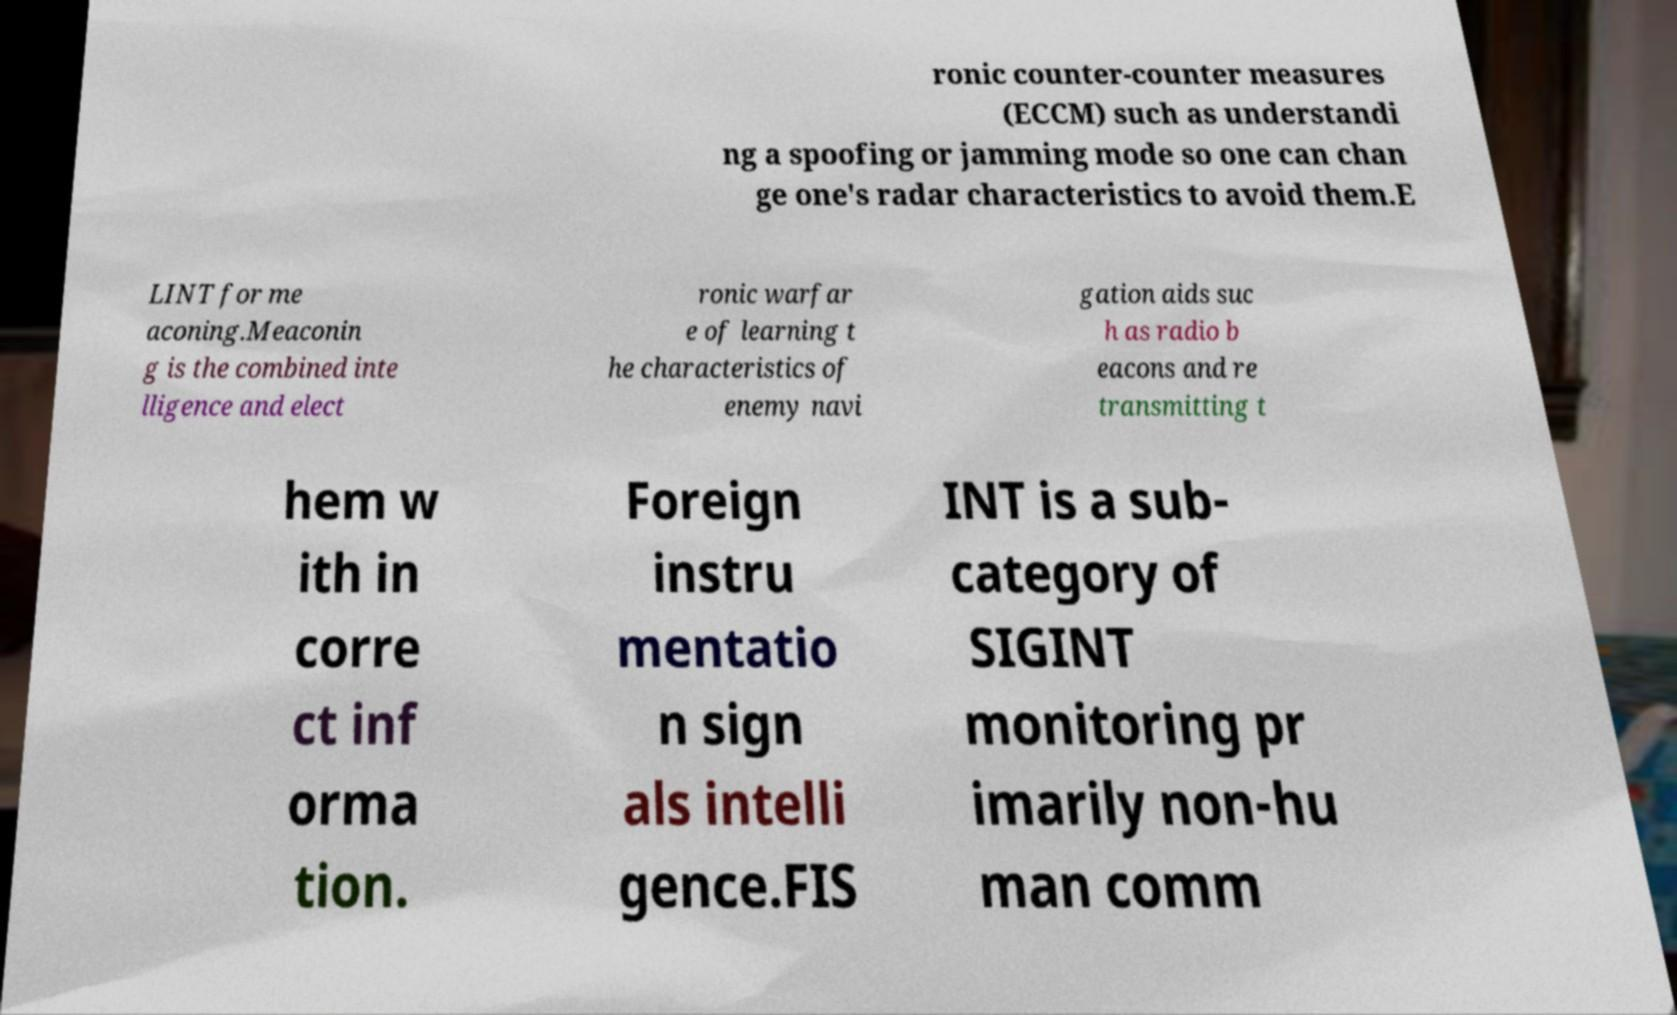Can you accurately transcribe the text from the provided image for me? ronic counter-counter measures (ECCM) such as understandi ng a spoofing or jamming mode so one can chan ge one's radar characteristics to avoid them.E LINT for me aconing.Meaconin g is the combined inte lligence and elect ronic warfar e of learning t he characteristics of enemy navi gation aids suc h as radio b eacons and re transmitting t hem w ith in corre ct inf orma tion. Foreign instru mentatio n sign als intelli gence.FIS INT is a sub- category of SIGINT monitoring pr imarily non-hu man comm 